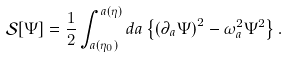Convert formula to latex. <formula><loc_0><loc_0><loc_500><loc_500>\mathcal { S } [ \Psi ] = \frac { 1 } { 2 } \int _ { a ( \eta _ { 0 } ) } ^ { a ( \eta ) } d a \left \{ \left ( \partial _ { a } \Psi \right ) ^ { 2 } - { \omega } _ { a } ^ { 2 } \Psi ^ { 2 } \right \} .</formula> 